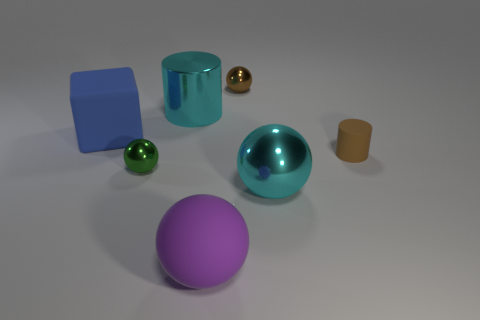There is a large ball that is right of the sphere that is in front of the big cyan sphere; are there any brown objects to the right of it? Upon examining the image, it appears there are no brown objects to the right of the large sphere as described in your initial query. The objects in the image include a purple sphere, a cyan sphere, a green sphere, a golden sphere, a cyan cylinder, a brown cylinder, and a blue cube. The only brown object present, the cylinder, is located to the left of the cyan sphere, not the right. 